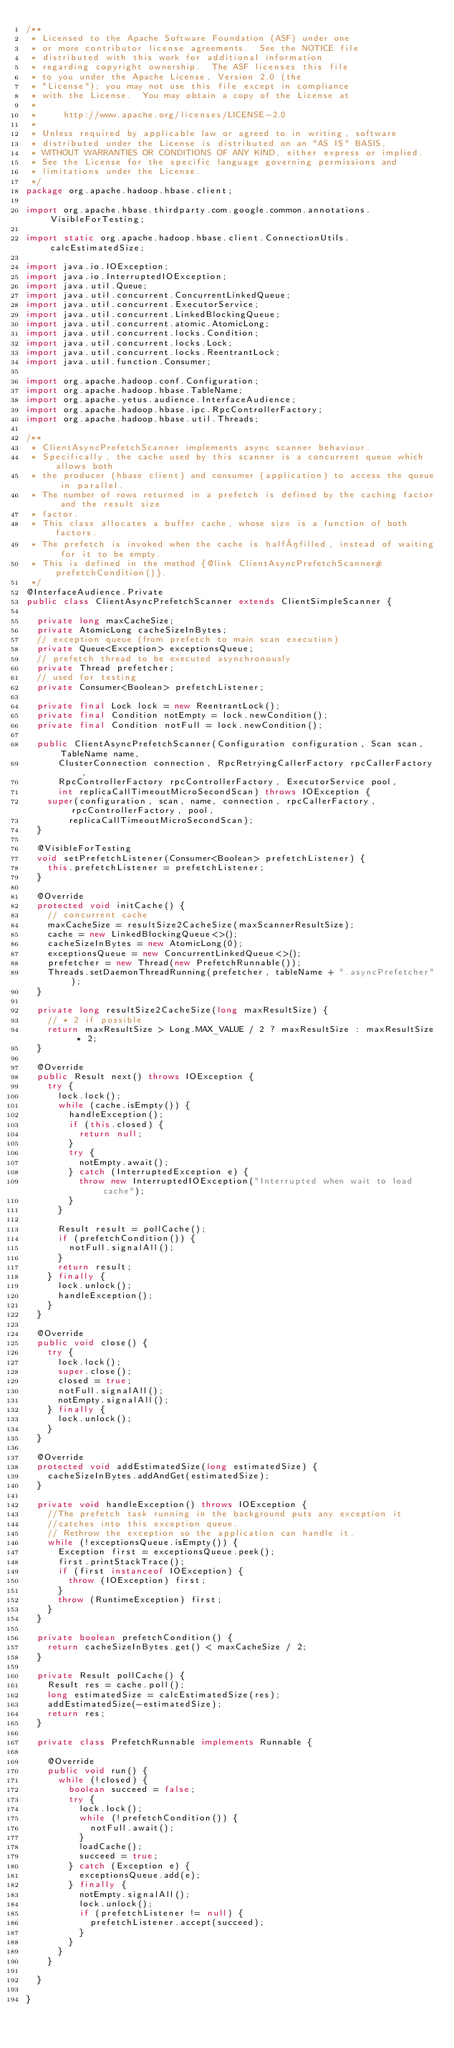Convert code to text. <code><loc_0><loc_0><loc_500><loc_500><_Java_>/**
 * Licensed to the Apache Software Foundation (ASF) under one
 * or more contributor license agreements.  See the NOTICE file
 * distributed with this work for additional information
 * regarding copyright ownership.  The ASF licenses this file
 * to you under the Apache License, Version 2.0 (the
 * "License"); you may not use this file except in compliance
 * with the License.  You may obtain a copy of the License at
 *
 *     http://www.apache.org/licenses/LICENSE-2.0
 *
 * Unless required by applicable law or agreed to in writing, software
 * distributed under the License is distributed on an "AS IS" BASIS,
 * WITHOUT WARRANTIES OR CONDITIONS OF ANY KIND, either express or implied.
 * See the License for the specific language governing permissions and
 * limitations under the License.
 */
package org.apache.hadoop.hbase.client;

import org.apache.hbase.thirdparty.com.google.common.annotations.VisibleForTesting;

import static org.apache.hadoop.hbase.client.ConnectionUtils.calcEstimatedSize;

import java.io.IOException;
import java.io.InterruptedIOException;
import java.util.Queue;
import java.util.concurrent.ConcurrentLinkedQueue;
import java.util.concurrent.ExecutorService;
import java.util.concurrent.LinkedBlockingQueue;
import java.util.concurrent.atomic.AtomicLong;
import java.util.concurrent.locks.Condition;
import java.util.concurrent.locks.Lock;
import java.util.concurrent.locks.ReentrantLock;
import java.util.function.Consumer;

import org.apache.hadoop.conf.Configuration;
import org.apache.hadoop.hbase.TableName;
import org.apache.yetus.audience.InterfaceAudience;
import org.apache.hadoop.hbase.ipc.RpcControllerFactory;
import org.apache.hadoop.hbase.util.Threads;

/**
 * ClientAsyncPrefetchScanner implements async scanner behaviour.
 * Specifically, the cache used by this scanner is a concurrent queue which allows both
 * the producer (hbase client) and consumer (application) to access the queue in parallel.
 * The number of rows returned in a prefetch is defined by the caching factor and the result size
 * factor.
 * This class allocates a buffer cache, whose size is a function of both factors.
 * The prefetch is invoked when the cache is half­filled, instead of waiting for it to be empty.
 * This is defined in the method {@link ClientAsyncPrefetchScanner#prefetchCondition()}.
 */
@InterfaceAudience.Private
public class ClientAsyncPrefetchScanner extends ClientSimpleScanner {

  private long maxCacheSize;
  private AtomicLong cacheSizeInBytes;
  // exception queue (from prefetch to main scan execution)
  private Queue<Exception> exceptionsQueue;
  // prefetch thread to be executed asynchronously
  private Thread prefetcher;
  // used for testing
  private Consumer<Boolean> prefetchListener;

  private final Lock lock = new ReentrantLock();
  private final Condition notEmpty = lock.newCondition();
  private final Condition notFull = lock.newCondition();

  public ClientAsyncPrefetchScanner(Configuration configuration, Scan scan, TableName name,
      ClusterConnection connection, RpcRetryingCallerFactory rpcCallerFactory,
      RpcControllerFactory rpcControllerFactory, ExecutorService pool,
      int replicaCallTimeoutMicroSecondScan) throws IOException {
    super(configuration, scan, name, connection, rpcCallerFactory, rpcControllerFactory, pool,
        replicaCallTimeoutMicroSecondScan);
  }

  @VisibleForTesting
  void setPrefetchListener(Consumer<Boolean> prefetchListener) {
    this.prefetchListener = prefetchListener;
  }

  @Override
  protected void initCache() {
    // concurrent cache
    maxCacheSize = resultSize2CacheSize(maxScannerResultSize);
    cache = new LinkedBlockingQueue<>();
    cacheSizeInBytes = new AtomicLong(0);
    exceptionsQueue = new ConcurrentLinkedQueue<>();
    prefetcher = new Thread(new PrefetchRunnable());
    Threads.setDaemonThreadRunning(prefetcher, tableName + ".asyncPrefetcher");
  }

  private long resultSize2CacheSize(long maxResultSize) {
    // * 2 if possible
    return maxResultSize > Long.MAX_VALUE / 2 ? maxResultSize : maxResultSize * 2;
  }

  @Override
  public Result next() throws IOException {
    try {
      lock.lock();
      while (cache.isEmpty()) {
        handleException();
        if (this.closed) {
          return null;
        }
        try {
          notEmpty.await();
        } catch (InterruptedException e) {
          throw new InterruptedIOException("Interrupted when wait to load cache");
        }
      }

      Result result = pollCache();
      if (prefetchCondition()) {
        notFull.signalAll();
      }
      return result;
    } finally {
      lock.unlock();
      handleException();
    }
  }

  @Override
  public void close() {
    try {
      lock.lock();
      super.close();
      closed = true;
      notFull.signalAll();
      notEmpty.signalAll();
    } finally {
      lock.unlock();
    }
  }

  @Override
  protected void addEstimatedSize(long estimatedSize) {
    cacheSizeInBytes.addAndGet(estimatedSize);
  }

  private void handleException() throws IOException {
    //The prefetch task running in the background puts any exception it
    //catches into this exception queue.
    // Rethrow the exception so the application can handle it.
    while (!exceptionsQueue.isEmpty()) {
      Exception first = exceptionsQueue.peek();
      first.printStackTrace();
      if (first instanceof IOException) {
        throw (IOException) first;
      }
      throw (RuntimeException) first;
    }
  }

  private boolean prefetchCondition() {
    return cacheSizeInBytes.get() < maxCacheSize / 2;
  }

  private Result pollCache() {
    Result res = cache.poll();
    long estimatedSize = calcEstimatedSize(res);
    addEstimatedSize(-estimatedSize);
    return res;
  }

  private class PrefetchRunnable implements Runnable {

    @Override
    public void run() {
      while (!closed) {
        boolean succeed = false;
        try {
          lock.lock();
          while (!prefetchCondition()) {
            notFull.await();
          }
          loadCache();
          succeed = true;
        } catch (Exception e) {
          exceptionsQueue.add(e);
        } finally {
          notEmpty.signalAll();
          lock.unlock();
          if (prefetchListener != null) {
            prefetchListener.accept(succeed);
          }
        }
      }
    }

  }

}
</code> 